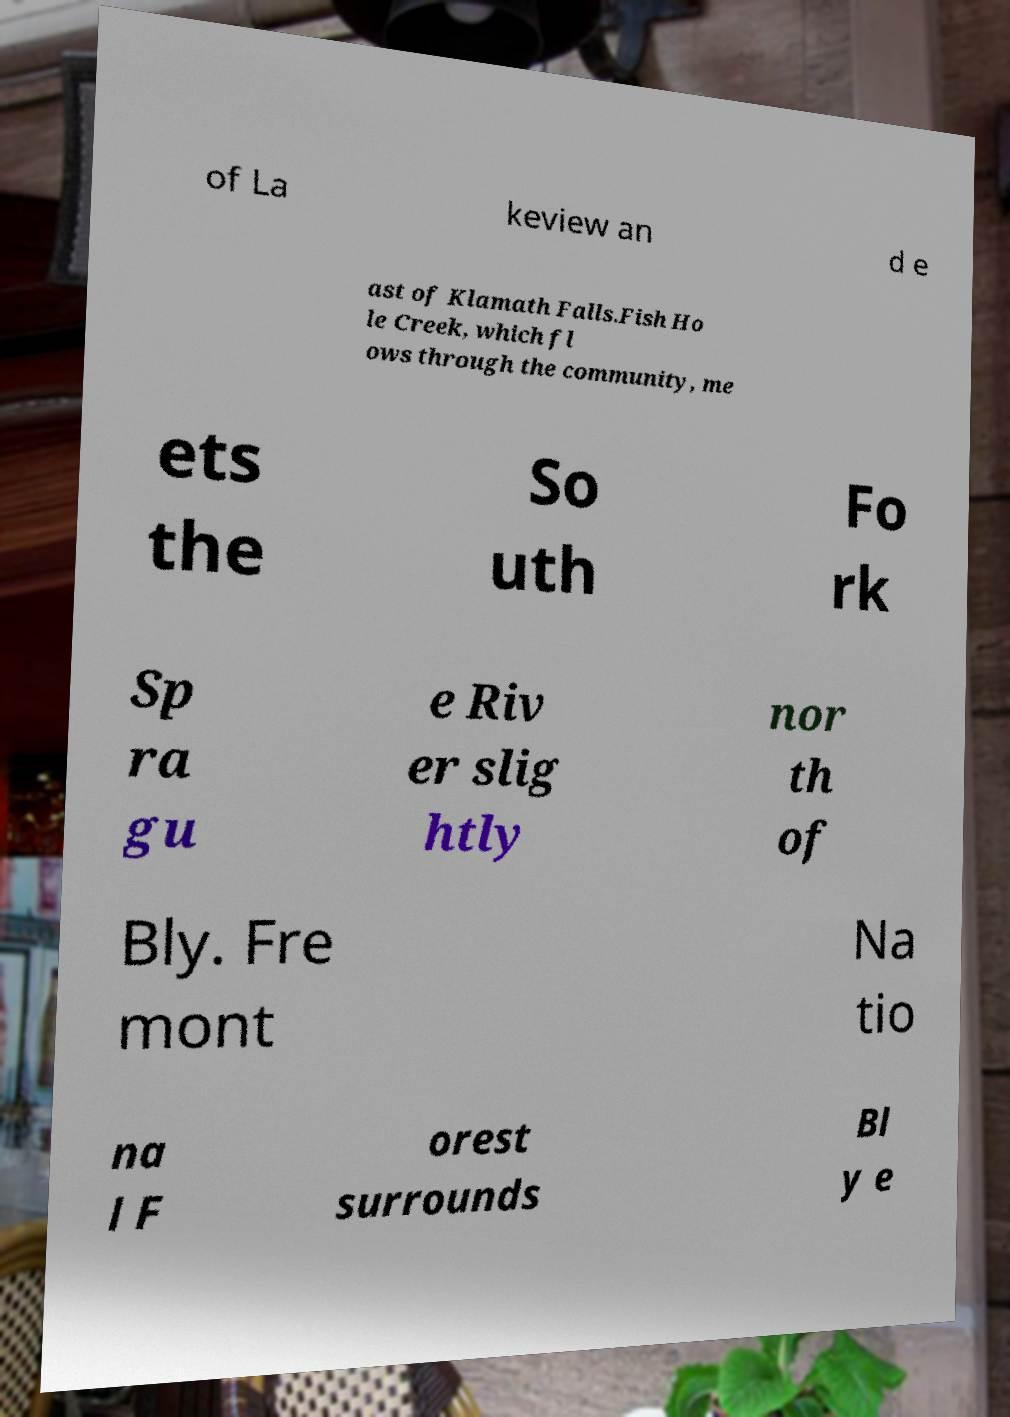For documentation purposes, I need the text within this image transcribed. Could you provide that? of La keview an d e ast of Klamath Falls.Fish Ho le Creek, which fl ows through the community, me ets the So uth Fo rk Sp ra gu e Riv er slig htly nor th of Bly. Fre mont Na tio na l F orest surrounds Bl y e 